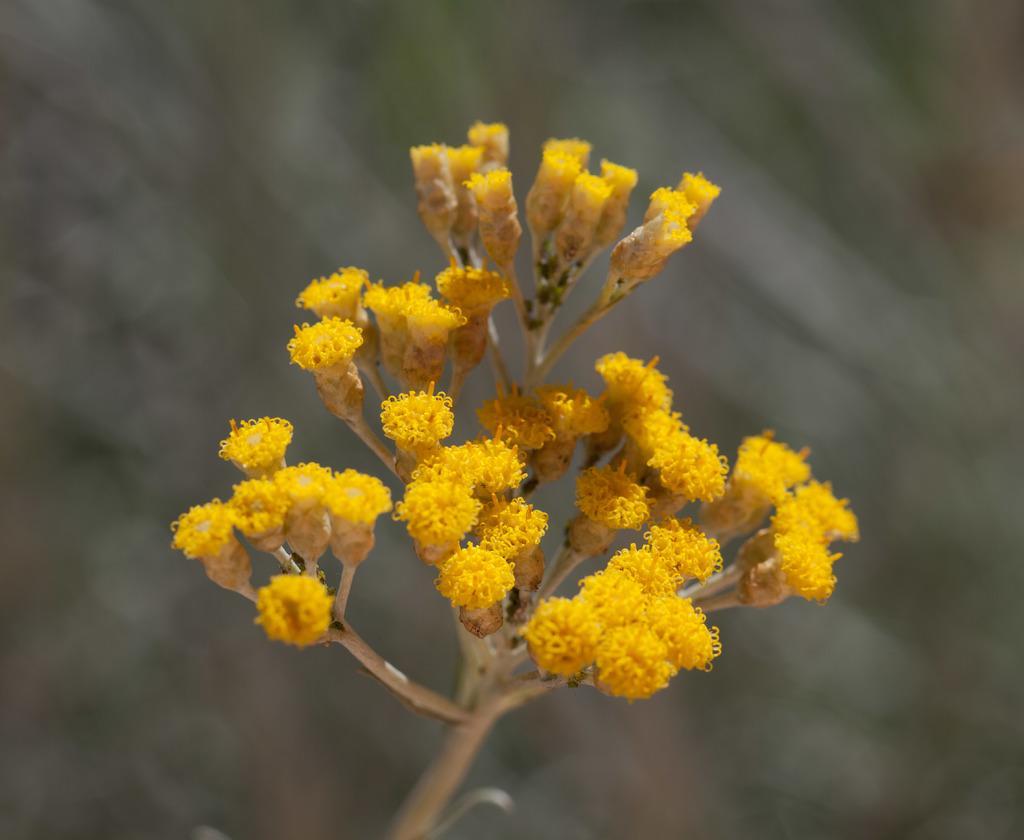Please provide a concise description of this image. In this picture, there are flowers to a plant which are in yellow in color. 